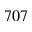Convert formula to latex. <formula><loc_0><loc_0><loc_500><loc_500>7 0 7</formula> 